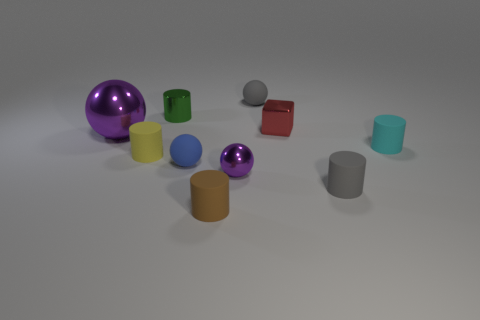Subtract all small spheres. How many spheres are left? 1 Subtract all cyan cylinders. How many cylinders are left? 4 Subtract 1 spheres. How many spheres are left? 3 Subtract all spheres. How many objects are left? 6 Subtract all green cubes. Subtract all cyan cylinders. How many cubes are left? 1 Subtract all green cubes. How many blue balls are left? 1 Subtract all gray matte balls. Subtract all big metallic things. How many objects are left? 8 Add 6 small yellow matte cylinders. How many small yellow matte cylinders are left? 7 Add 1 small blocks. How many small blocks exist? 2 Subtract 0 purple cylinders. How many objects are left? 10 